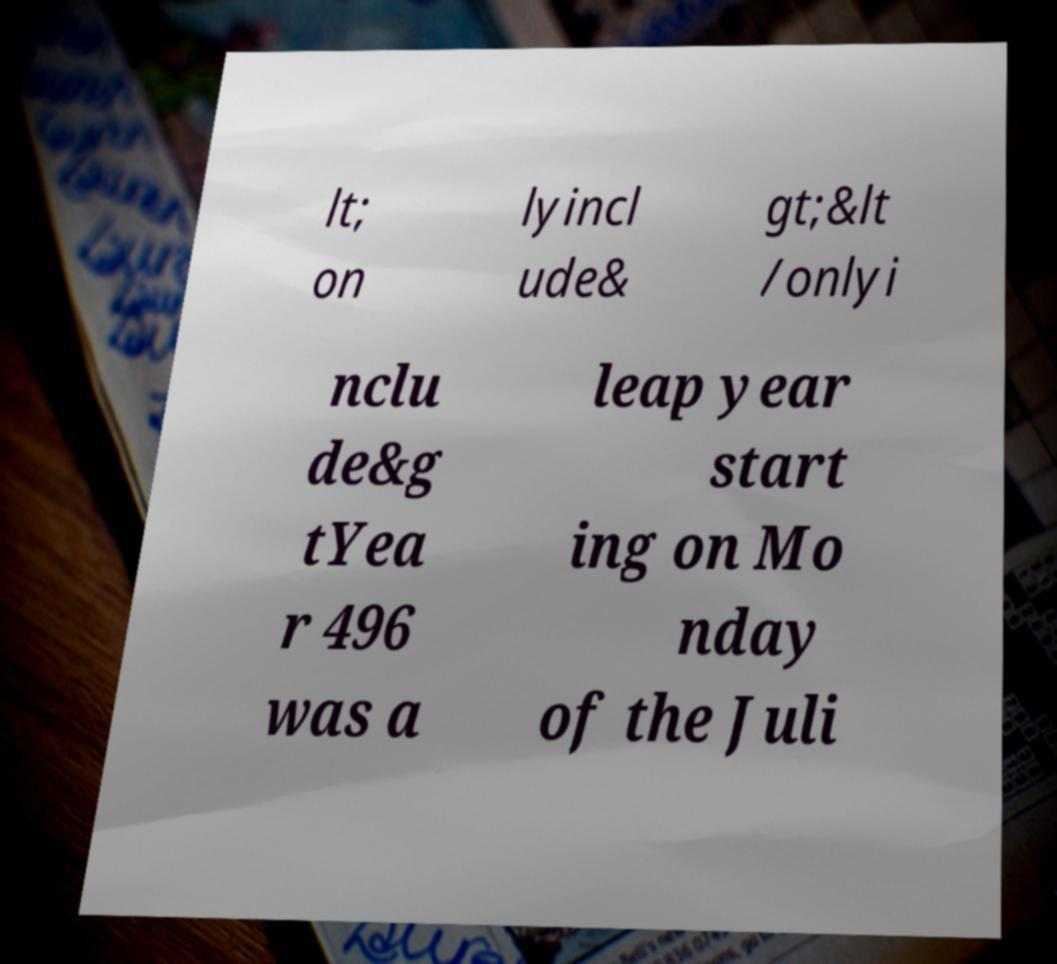What messages or text are displayed in this image? I need them in a readable, typed format. lt; on lyincl ude& gt;&lt /onlyi nclu de&g tYea r 496 was a leap year start ing on Mo nday of the Juli 